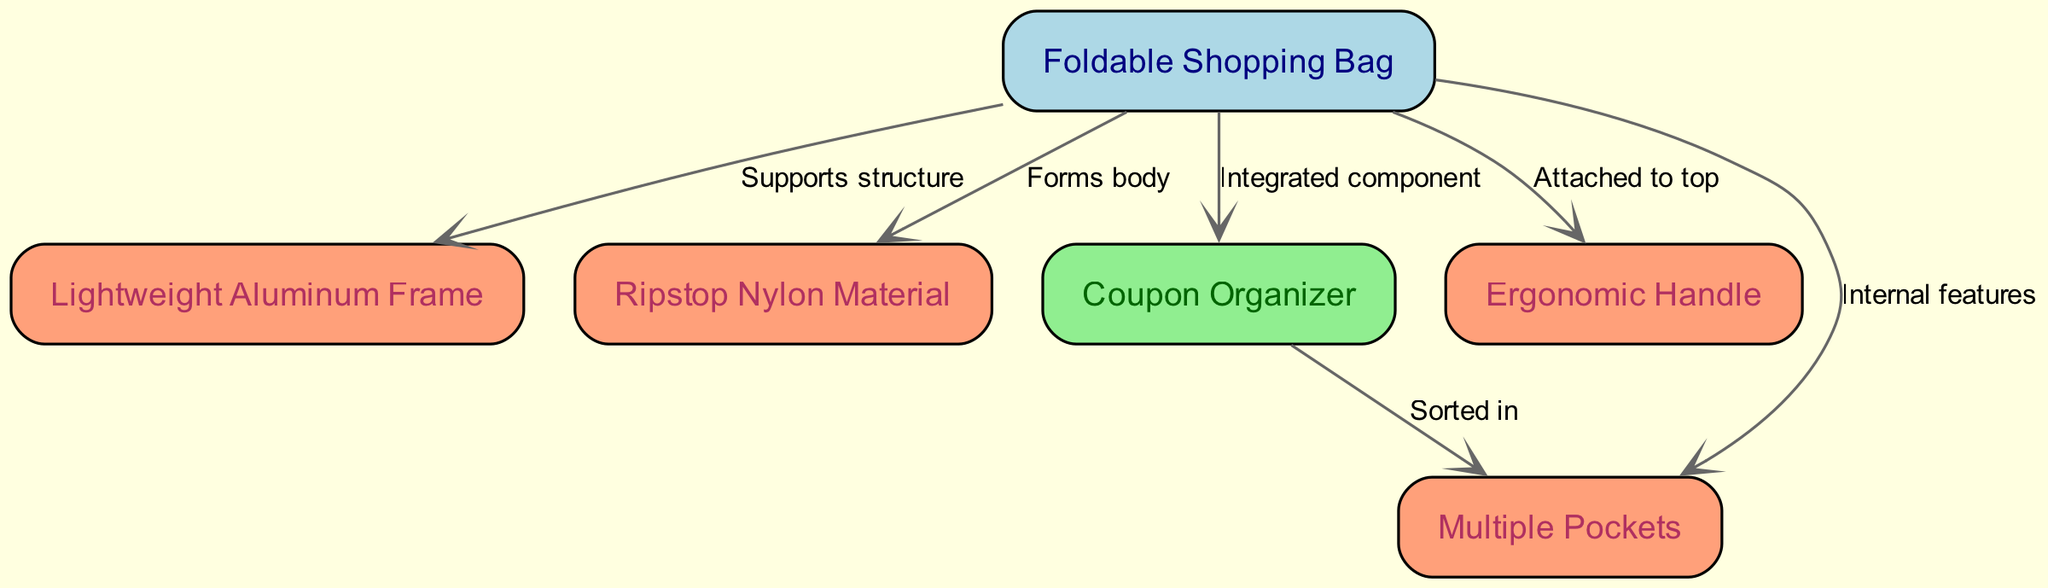What is the main component of the diagram? The main component of the diagram is represented by the node "Foldable Shopping Bag", which is central to the structure and interactions depicted in the diagram.
Answer: Foldable Shopping Bag How many nodes are in the diagram? By counting all the nodes listed, we see there are six nodes in total: "Foldable Shopping Bag", "Lightweight Aluminum Frame", "Ripstop Nylon Material", "Coupon Organizer", "Ergonomic Handle", and "Multiple Pockets".
Answer: 6 What supports the structure of the bag? The edge labeled "Supports structure" from "Foldable Shopping Bag" to "Lightweight Aluminum Frame" directly indicates that the frame supports the bag's structure.
Answer: Lightweight Aluminum Frame What forms the body of the bag? The edge labeled "Forms body" indicates that the "Ripstop Nylon Material" is what actually makes up the body of the bag, connecting it to the "Foldable Shopping Bag".
Answer: Ripstop Nylon Material How many edges connect the nodes? There are five edges in total that connect the nodes, as counted from the relationships specified in the diagram.
Answer: 5 Which element is integrated into the bag? The edge labeled "Integrated component" clearly shows that the "Coupon Organizer" is an integrated part of the "Foldable Shopping Bag".
Answer: Coupon Organizer How are the pockets related to the coupon organizer? The edge labeled "Sorted in" indicates that the "Multiple Pockets" are organized in relation to the "Coupon Organizer", signifying a direct relationship for organization within the bag.
Answer: Sorted in What is attached to the top of the bag? The edge labeled "Attached to top" identifies that the "Ergonomic Handle" is the element connected to the top of the bag, highlighting its position.
Answer: Ergonomic Handle Which material is used for the bag's body? The node "Ripstop Nylon Material" specifies the type of material used to form the body of the "Foldable Shopping Bag".
Answer: Ripstop Nylon Material 